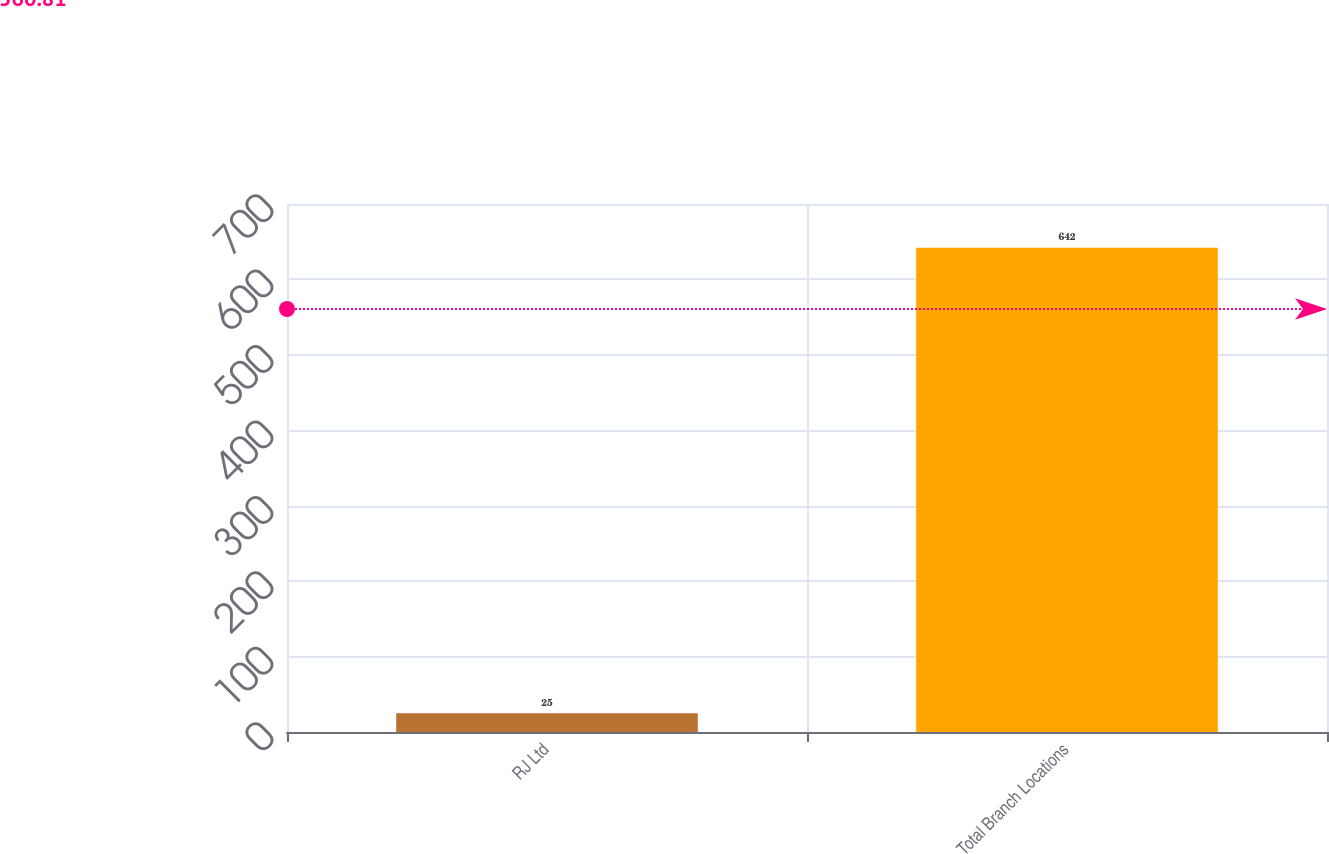Convert chart to OTSL. <chart><loc_0><loc_0><loc_500><loc_500><bar_chart><fcel>RJ Ltd<fcel>Total Branch Locations<nl><fcel>25<fcel>642<nl></chart> 